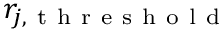Convert formula to latex. <formula><loc_0><loc_0><loc_500><loc_500>r _ { j , t h r e s h o l d }</formula> 